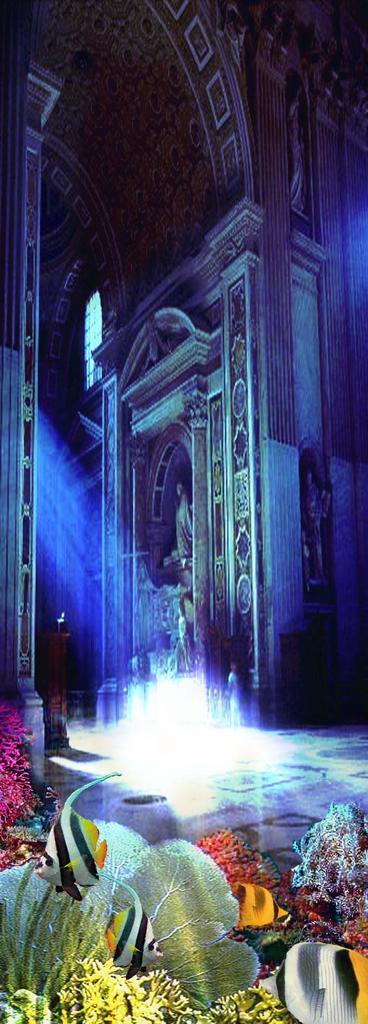Describe this image in one or two sentences. In the picture we can see a historical wall with some sculptures to it with some designs and besides, we can see some fishes and water plants in the aquarium. 